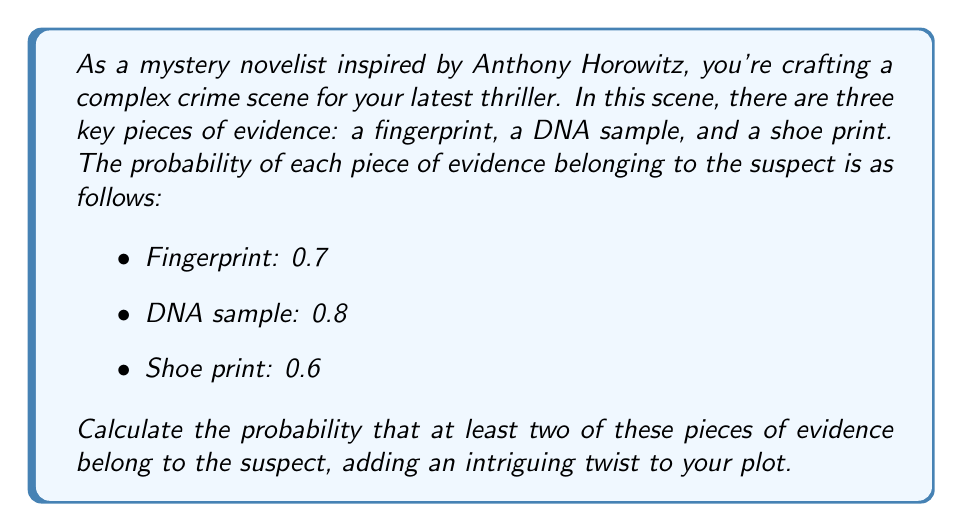Provide a solution to this math problem. To solve this problem, we'll use the concept of probability of combined events. Let's approach this step-by-step:

1) First, let's define our events:
   A: Fingerprint belongs to suspect
   B: DNA sample belongs to suspect
   C: Shoe print belongs to suspect

2) We need to find P(at least two belong to suspect). This is equivalent to:
   P(all three) + P(exactly two)

3) P(all three) is straightforward:
   $$P(A \cap B \cap C) = 0.7 \times 0.8 \times 0.6 = 0.336$$

4) For P(exactly two), we need to sum the probabilities of each combination of two events occurring while the third doesn't:

   $$P(A \cap B \cap \overline{C}) + P(A \cap \overline{B} \cap C) + P(\overline{A} \cap B \cap C)$$

   $$= (0.7 \times 0.8 \times 0.4) + (0.7 \times 0.2 \times 0.6) + (0.3 \times 0.8 \times 0.6)$$
   $$= 0.224 + 0.084 + 0.144 = 0.452$$

5) Now, we sum the probabilities from steps 3 and 4:

   $$P(\text{at least two}) = P(\text{all three}) + P(\text{exactly two})$$
   $$= 0.336 + 0.452 = 0.788$$

Therefore, the probability that at least two pieces of evidence belong to the suspect is 0.788 or 78.8%.
Answer: The probability that at least two of the three pieces of evidence belong to the suspect is $0.788$ or $78.8\%$. 